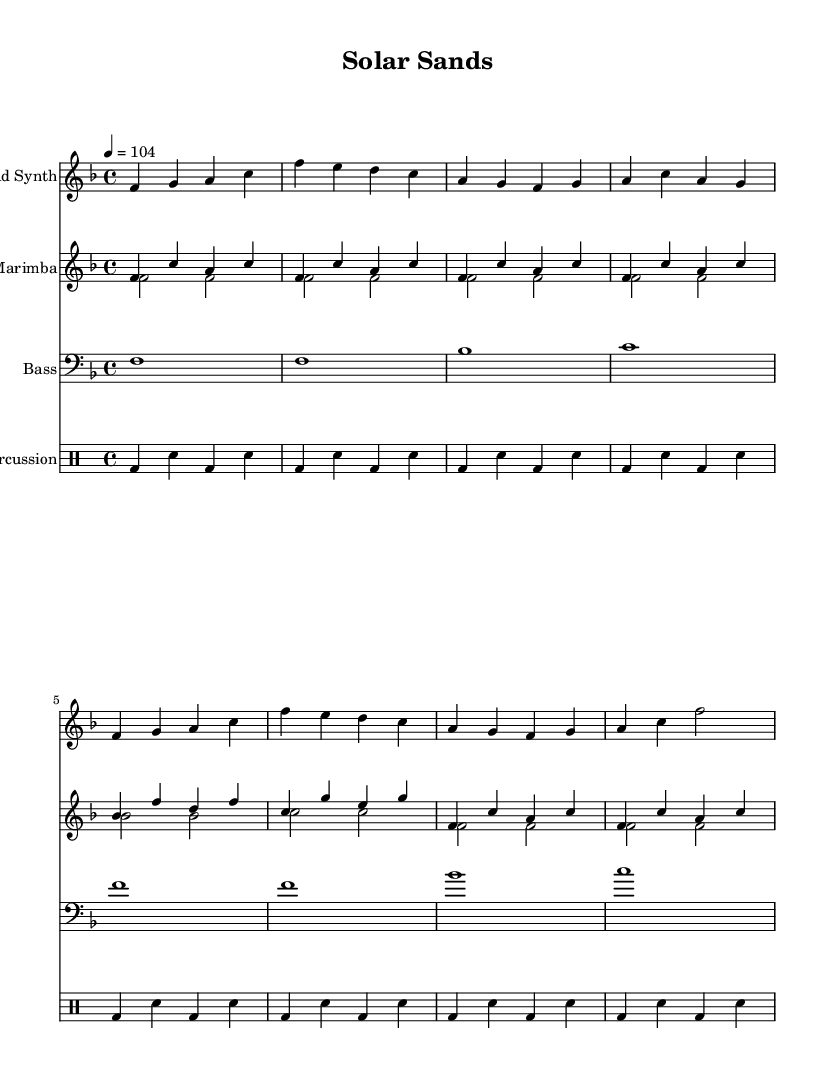What is the key signature of this music? The key signature indicated at the beginning of the score shows one flat, which corresponds to the key of F major.
Answer: F major What is the time signature of the piece? The time signature is indicated at the beginning of the score as 4/4, meaning there are four beats in each measure and the quarter note receives one beat.
Answer: 4/4 What is the tempo marking in this score? The tempo marking specified in the score states '4 = 104', which indicates that a quarter note beats at a speed of 104 beats per minute.
Answer: 104 How many measures are in the lead synth part? By counting the distinct measures in the lead synth notation, there are a total of eight measures that can be identified.
Answer: 8 What is the main rhythmic pattern found in the percussion section? The percussion section consists predominantly of a bass drum playing on the beat combined with snare hits on alternating offbeats, creating a consistent rhythmic pattern.
Answer: Bass and snare Which instruments are featured in this score? The score features four distinct instrumental parts: a lead synth, marimba, bass, and percussion, showcasing a blend of electronic and acoustic sounds.
Answer: Lead synth, marimba, bass, percussion What type of piece is "Solar Sands"? Given the characteristics such as the tempo, instrumentation, and rhythmic style, it can be categorized as a tropical house track which aligns with dance music conventions.
Answer: Tropical house 